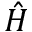<formula> <loc_0><loc_0><loc_500><loc_500>\hat { H }</formula> 